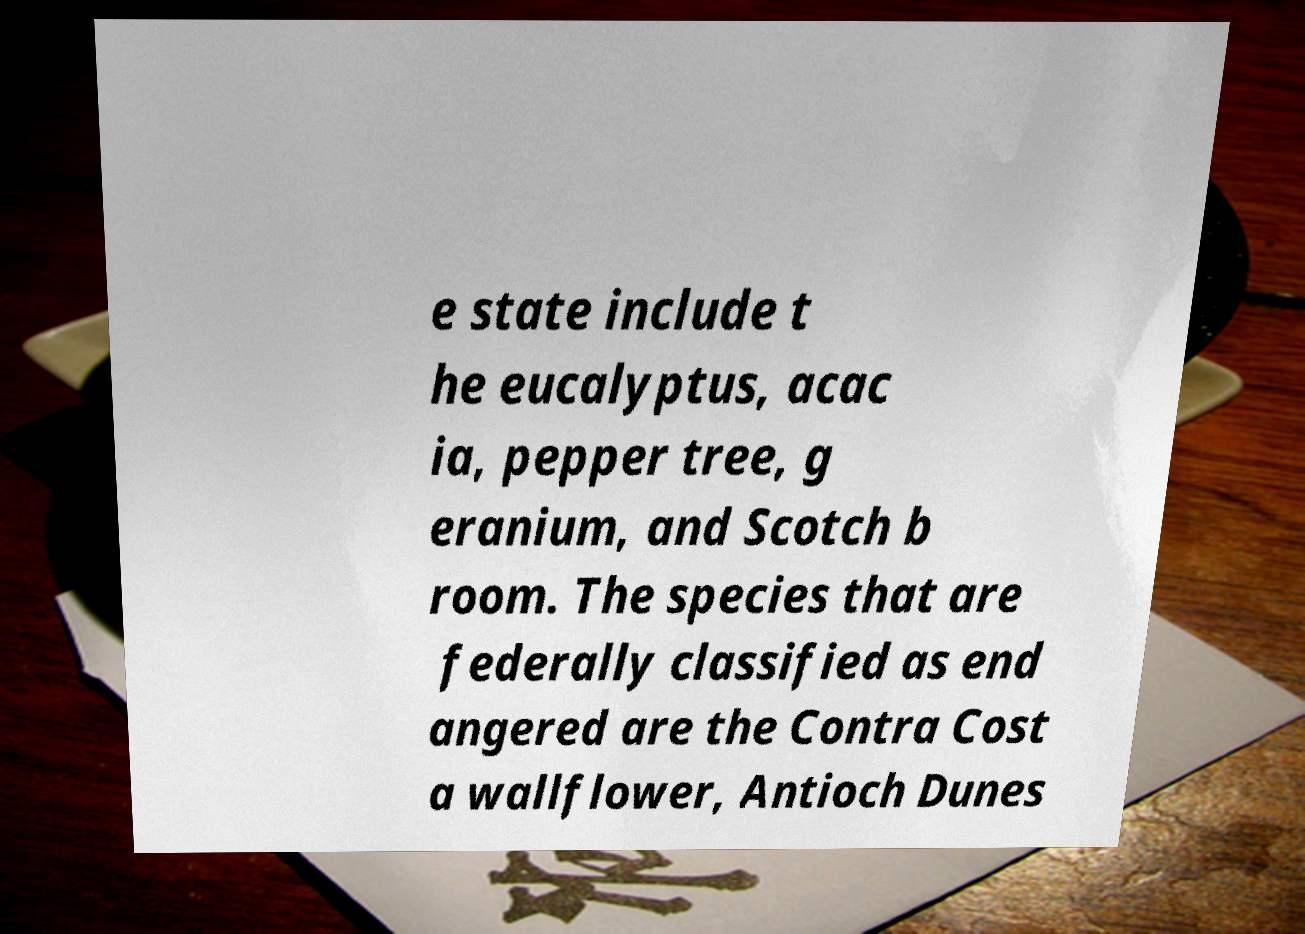Please read and relay the text visible in this image. What does it say? e state include t he eucalyptus, acac ia, pepper tree, g eranium, and Scotch b room. The species that are federally classified as end angered are the Contra Cost a wallflower, Antioch Dunes 